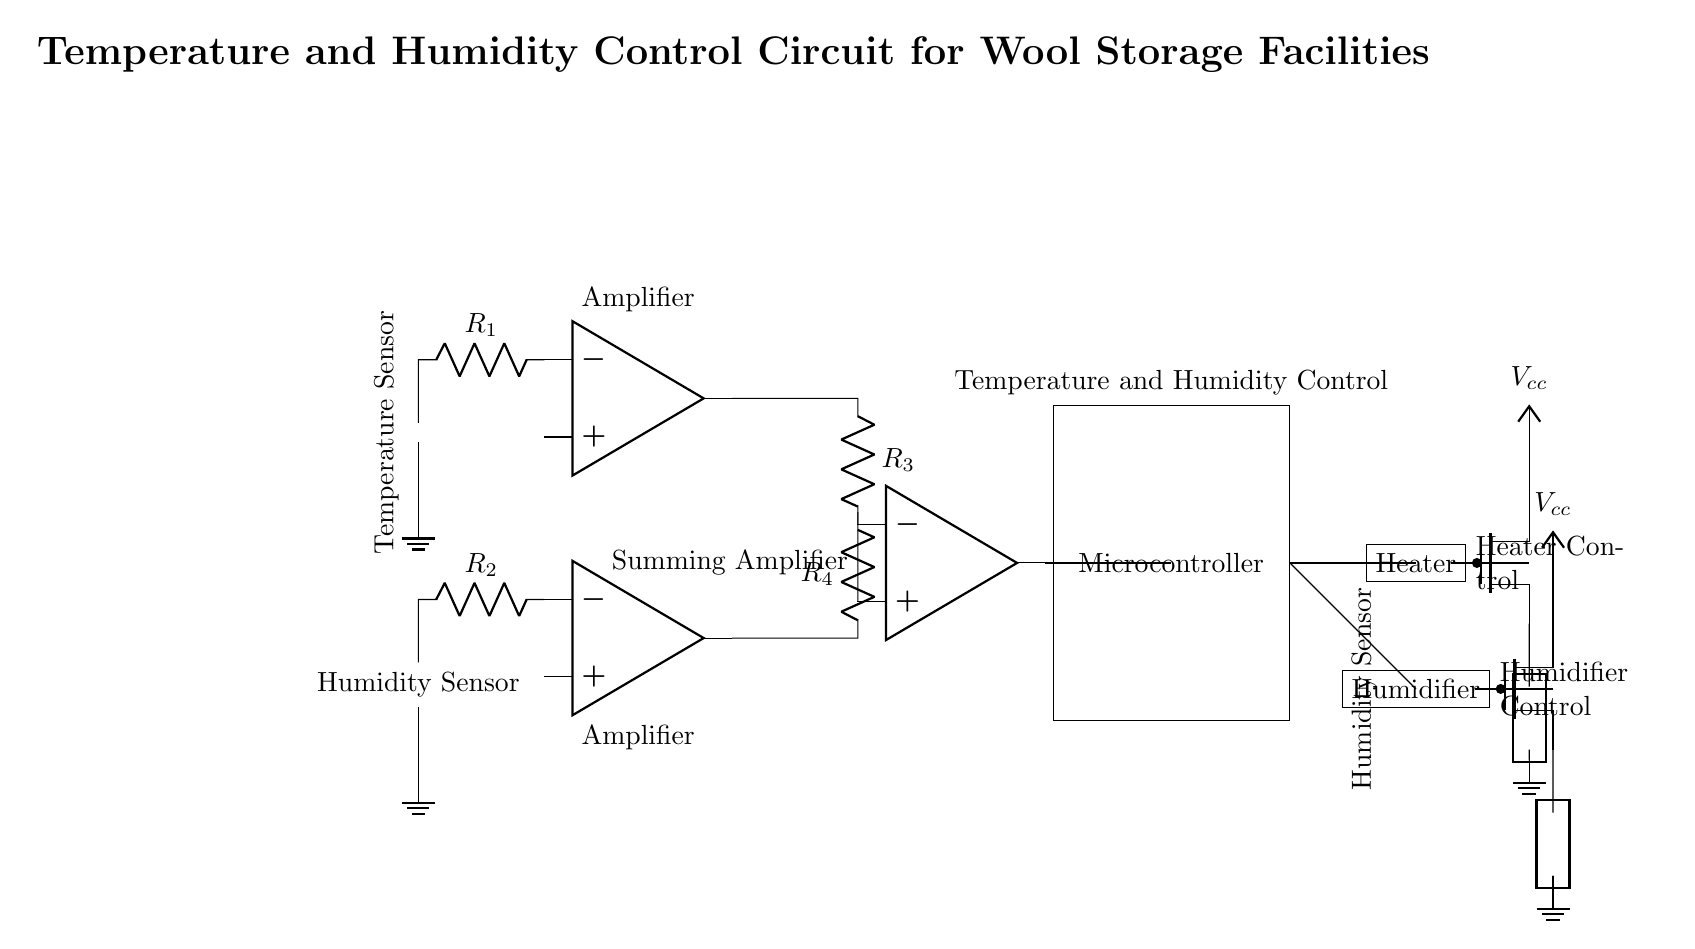What type of sensor is used for temperature measurement? The circuit diagram labels the component as a "Temperature Sensor." The visual representation indicates that it detects temperature changes, making it a sensor specifically designed for that purpose.
Answer: Temperature Sensor What does the microcontroller control in the circuit? The microcontroller, as depicted in the circuit, connects to both a heater and a humidifier. The labels indicate that it manages temperature via the heater and humidity via the humidifier, integrating these functions for optimal wool storage conditions.
Answer: Heater and Humidifier How many amplifiers are used in this circuit? There are three amplifiers in the circuit: two connected directly to the sensors and one summing amplifier. This can be counted by identifying the amplifier symbols and their connections in the diagram, clearly indicating three amplifiers in total.
Answer: Three What type of device controls the humidity? The circuit depicts a "Humidifier" which is controlled by the microcontroller. The connection from the microcontroller to the humidifier indicates that it is responsible for modulating humidity levels within the storage facility.
Answer: Humidifier What kind of component connects the temperature sensor to the first amplifier? A resistor labeled "R1" is shown connecting the temperature sensor to the first amplifier. The circuit indicates that this resistor plays a role in conditioning the sensor’s output before amplification.
Answer: Resistor What is the function of the PMOS in the circuit? The PMOS transistors function as switches for controlling the power to the heater and humidifier, as indicated by their placement and labels. The connections to the microcontroller imply that they allow or cut off current flow based on signals from the controller.
Answer: Switching Control 